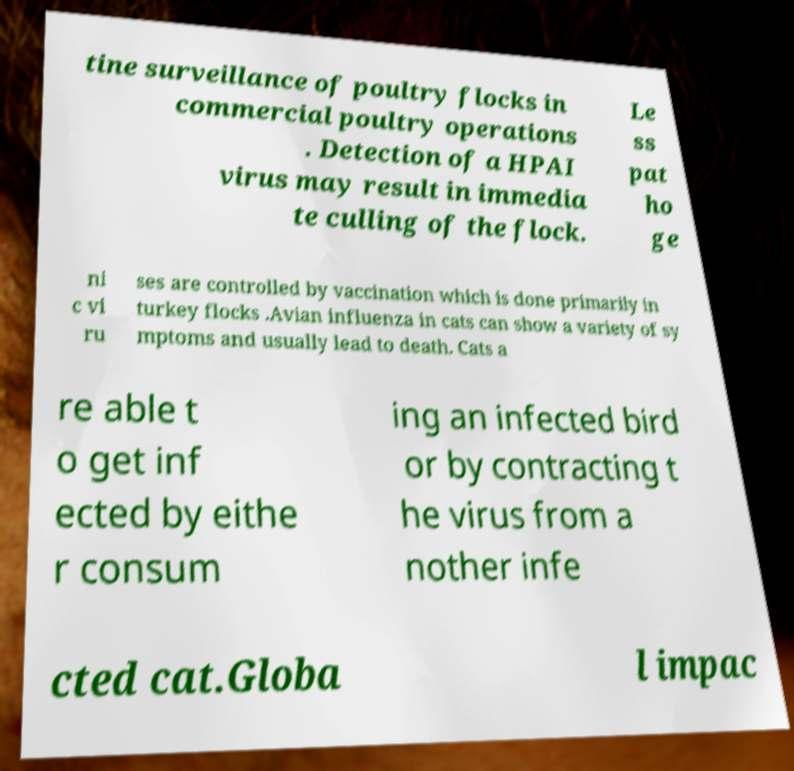Can you accurately transcribe the text from the provided image for me? tine surveillance of poultry flocks in commercial poultry operations . Detection of a HPAI virus may result in immedia te culling of the flock. Le ss pat ho ge ni c vi ru ses are controlled by vaccination which is done primarily in turkey flocks .Avian influenza in cats can show a variety of sy mptoms and usually lead to death. Cats a re able t o get inf ected by eithe r consum ing an infected bird or by contracting t he virus from a nother infe cted cat.Globa l impac 